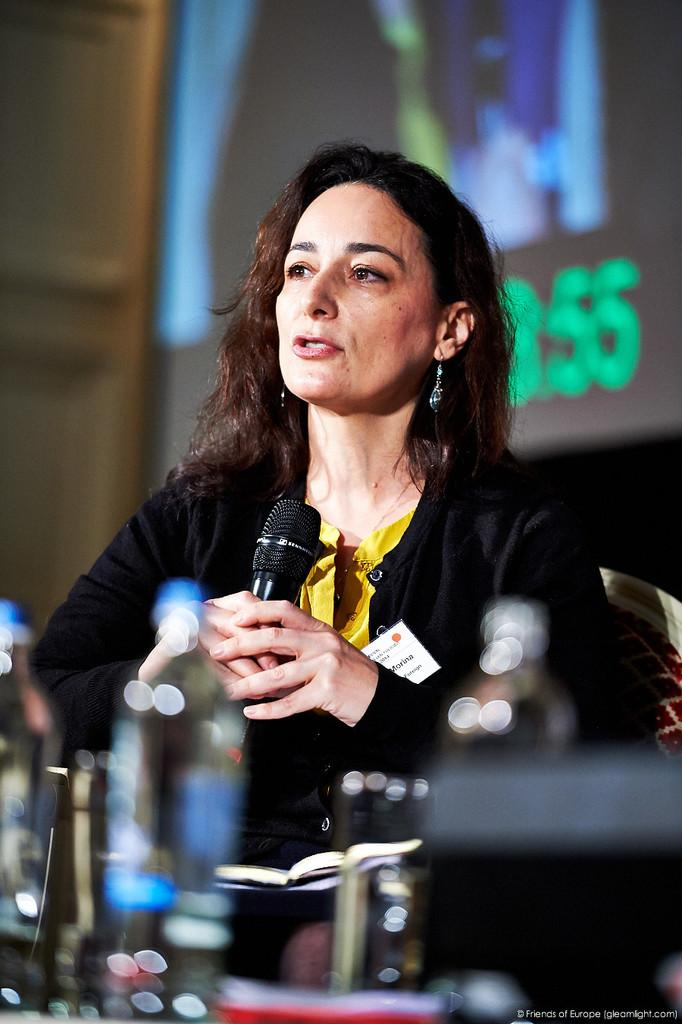Who is the main subject in the image? There is a woman in the image. What is the woman doing in the image? The woman is sitting on a chair and holding a mic in her hand. What objects are in front of the woman? There are water bottles in front of her. What is visible behind the woman? There is a screen behind her. Can you see any feathers floating around the woman in the image? There are no feathers visible in the image. What type of earth is present in the image? The image does not depict any earth or soil; it features a woman sitting on a chair with a mic and a screen behind her. 